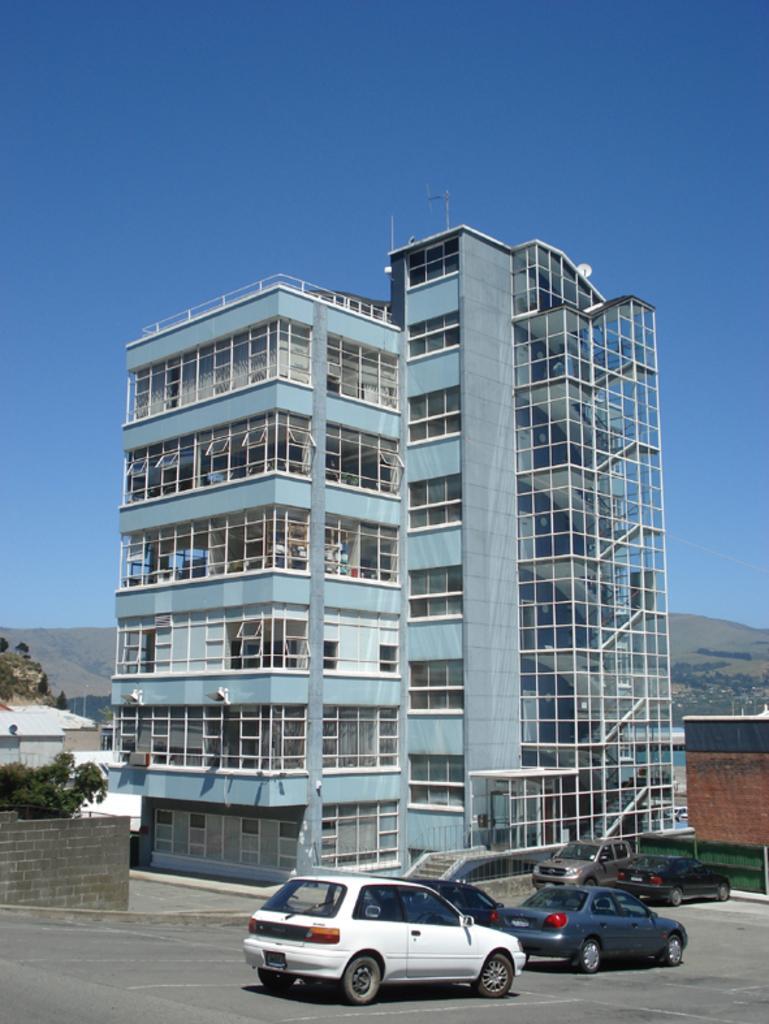How would you summarize this image in a sentence or two? There are cars and a wall at the bottom side of the image, there are buildings, trees, it seems like mountains and the sky in the background. 